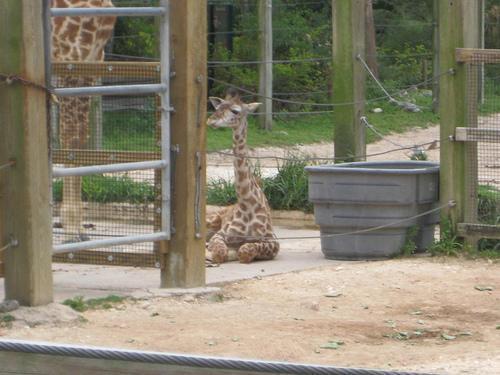How many giraffes are in the picture?
Give a very brief answer. 2. 